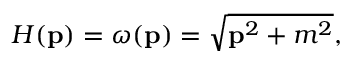Convert formula to latex. <formula><loc_0><loc_0><loc_500><loc_500>H ( { p } ) = \omega ( { p } ) = \sqrt { { p } ^ { 2 } + m ^ { 2 } } ,</formula> 